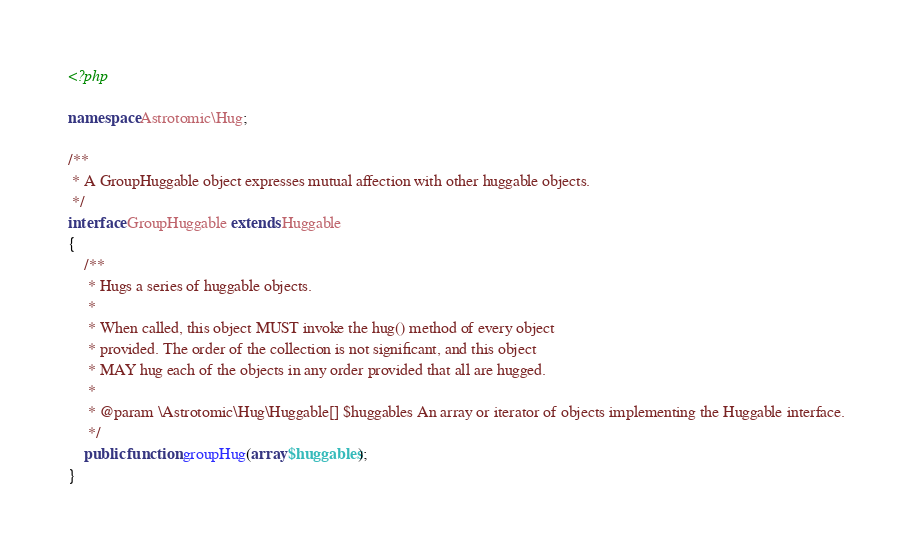<code> <loc_0><loc_0><loc_500><loc_500><_PHP_><?php

namespace Astrotomic\Hug;

/**
 * A GroupHuggable object expresses mutual affection with other huggable objects.
 */
interface GroupHuggable extends Huggable
{
    /**
     * Hugs a series of huggable objects.
     *
     * When called, this object MUST invoke the hug() method of every object
     * provided. The order of the collection is not significant, and this object
     * MAY hug each of the objects in any order provided that all are hugged.
     *
     * @param \Astrotomic\Hug\Huggable[] $huggables An array or iterator of objects implementing the Huggable interface.
     */
    public function groupHug(array $huggables);
}</code> 